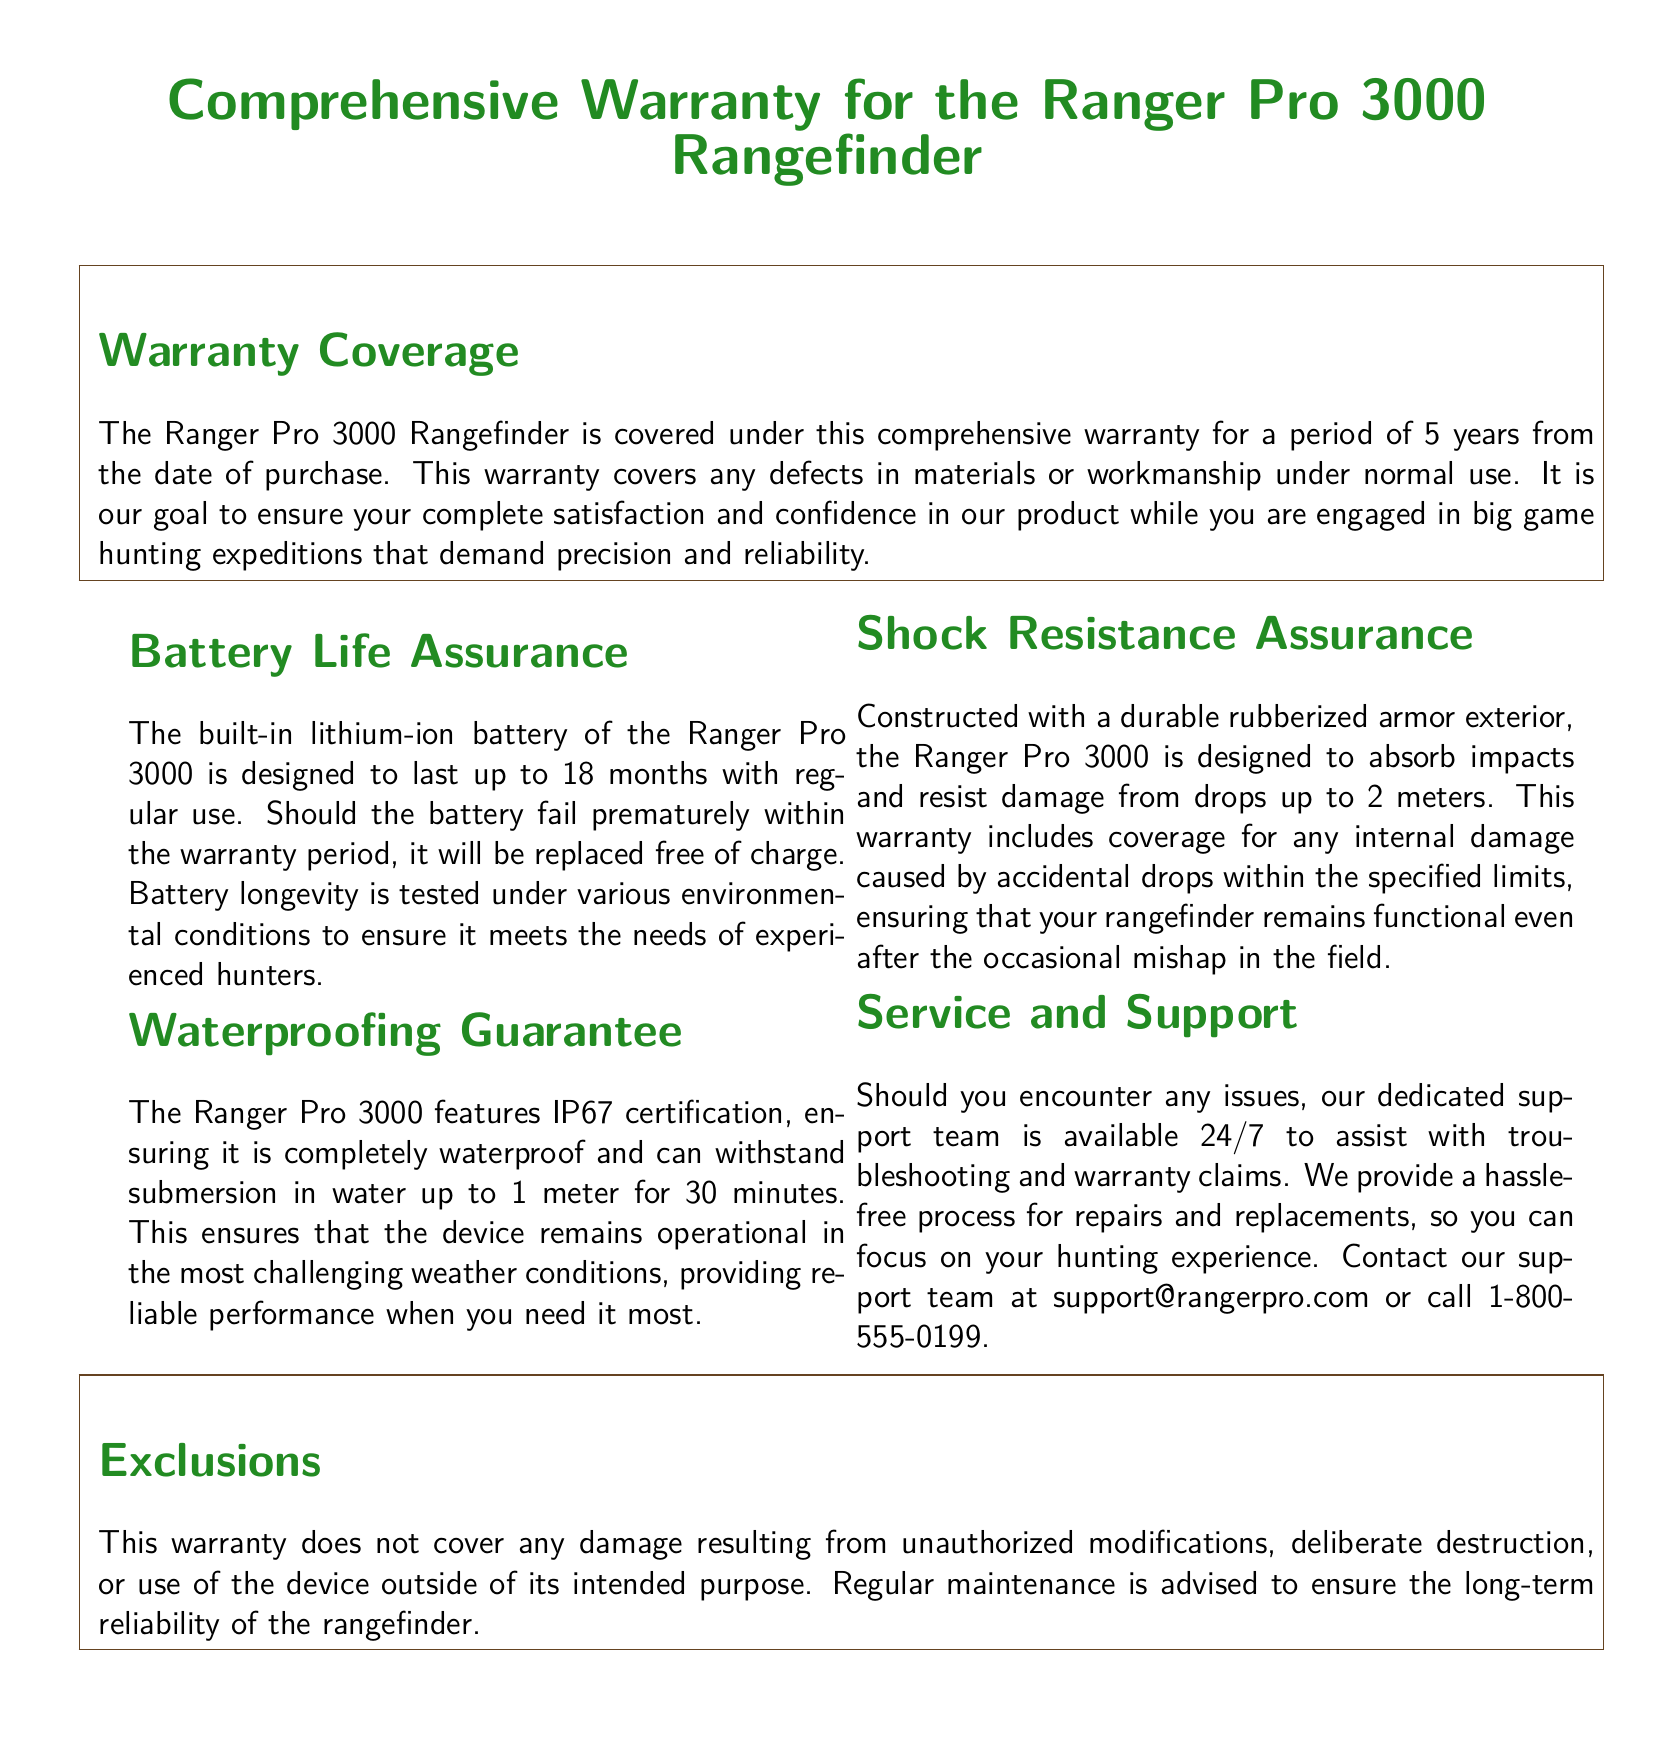what is the warranty period for the Ranger Pro 3000? The warranty period is specified as 5 years from the date of purchase.
Answer: 5 years what is the battery life of the Ranger Pro 3000? The document states that the built-in lithium-ion battery is designed to last up to 18 months with regular use.
Answer: 18 months what is the waterproof certification of the Ranger Pro 3000? The waterproof certification is stated as IP67, ensuring it can withstand specific conditions.
Answer: IP67 how deep can the Ranger Pro 3000 be submerged in water? The document mentions that it can withstand submersion in water up to 1 meter.
Answer: 1 meter how high can the Ranger Pro 3000 be dropped without damage? The rangefinder is designed to handle drops from up to 2 meters without sustaining damage.
Answer: 2 meters what type of support is provided for warranty claims? The document outlines that the support team is available 24/7 to assist with troubleshooting and warranty claims.
Answer: 24/7 which type of damage is not covered under the warranty? The document specifies that damage resulting from unauthorized modifications is not covered.
Answer: Unauthorized modifications what type of exterior protection does the Ranger Pro 3000 have? The rangefinder features a durable rubberized armor exterior for impact absorption.
Answer: Rubberized armor how can customers contact the support team? Customers can contact the support team via email or phone as mentioned in the document.
Answer: support@rangerpro.com or 1-800-555-0199 